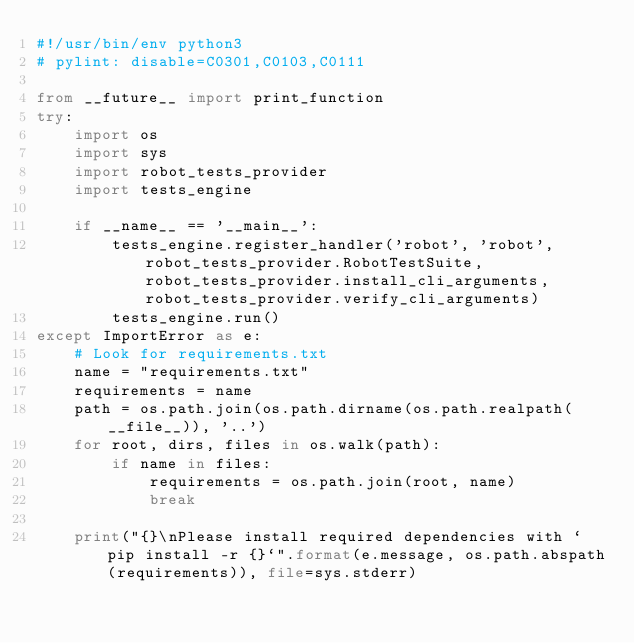Convert code to text. <code><loc_0><loc_0><loc_500><loc_500><_Python_>#!/usr/bin/env python3
# pylint: disable=C0301,C0103,C0111

from __future__ import print_function
try:
    import os
    import sys
    import robot_tests_provider
    import tests_engine

    if __name__ == '__main__':
        tests_engine.register_handler('robot', 'robot', robot_tests_provider.RobotTestSuite, robot_tests_provider.install_cli_arguments, robot_tests_provider.verify_cli_arguments)
        tests_engine.run()
except ImportError as e:
    # Look for requirements.txt
    name = "requirements.txt"
    requirements = name
    path = os.path.join(os.path.dirname(os.path.realpath(__file__)), '..')
    for root, dirs, files in os.walk(path):
        if name in files:
            requirements = os.path.join(root, name)
            break

    print("{}\nPlease install required dependencies with `pip install -r {}`".format(e.message, os.path.abspath(requirements)), file=sys.stderr)
</code> 